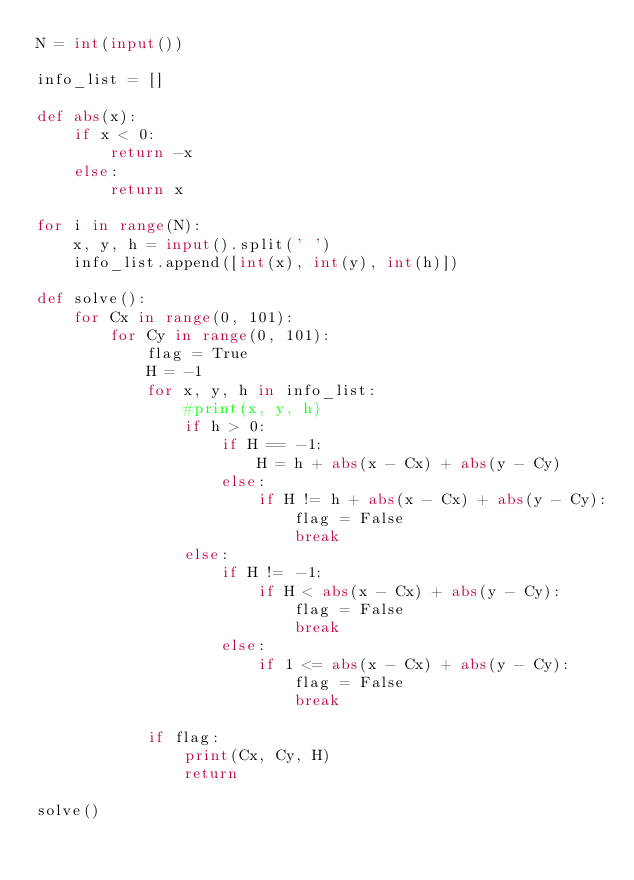<code> <loc_0><loc_0><loc_500><loc_500><_Python_>N = int(input())

info_list = []

def abs(x):
    if x < 0:
        return -x
    else:
        return x

for i in range(N):
    x, y, h = input().split(' ')
    info_list.append([int(x), int(y), int(h)])

def solve():
    for Cx in range(0, 101):
        for Cy in range(0, 101):
            flag = True
            H = -1
            for x, y, h in info_list:
                #print(x, y, h)
                if h > 0:
                    if H == -1:
                        H = h + abs(x - Cx) + abs(y - Cy)
                    else:
                        if H != h + abs(x - Cx) + abs(y - Cy):
                            flag = False
                            break
                else:
                    if H != -1:
                        if H < abs(x - Cx) + abs(y - Cy):
                            flag = False
                            break
                    else:
                        if 1 <= abs(x - Cx) + abs(y - Cy):
                            flag = False
                            break

            if flag:
                print(Cx, Cy, H)
                return

solve()

</code> 